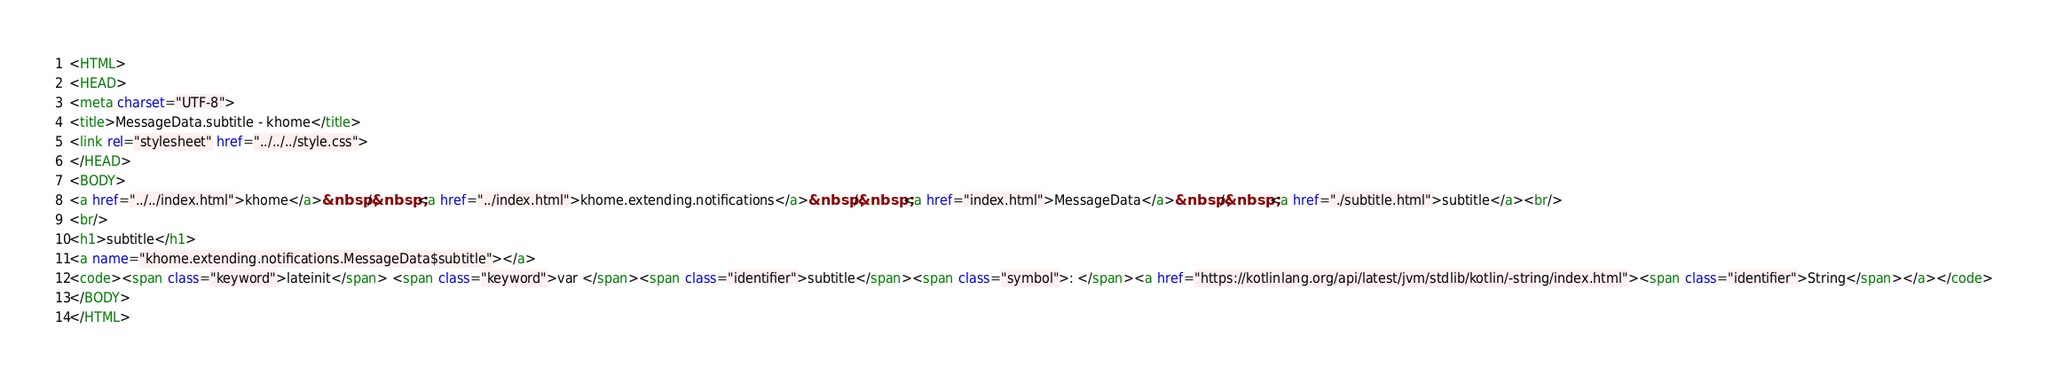Convert code to text. <code><loc_0><loc_0><loc_500><loc_500><_HTML_><HTML>
<HEAD>
<meta charset="UTF-8">
<title>MessageData.subtitle - khome</title>
<link rel="stylesheet" href="../../../style.css">
</HEAD>
<BODY>
<a href="../../index.html">khome</a>&nbsp;/&nbsp;<a href="../index.html">khome.extending.notifications</a>&nbsp;/&nbsp;<a href="index.html">MessageData</a>&nbsp;/&nbsp;<a href="./subtitle.html">subtitle</a><br/>
<br/>
<h1>subtitle</h1>
<a name="khome.extending.notifications.MessageData$subtitle"></a>
<code><span class="keyword">lateinit</span> <span class="keyword">var </span><span class="identifier">subtitle</span><span class="symbol">: </span><a href="https://kotlinlang.org/api/latest/jvm/stdlib/kotlin/-string/index.html"><span class="identifier">String</span></a></code>
</BODY>
</HTML>
</code> 